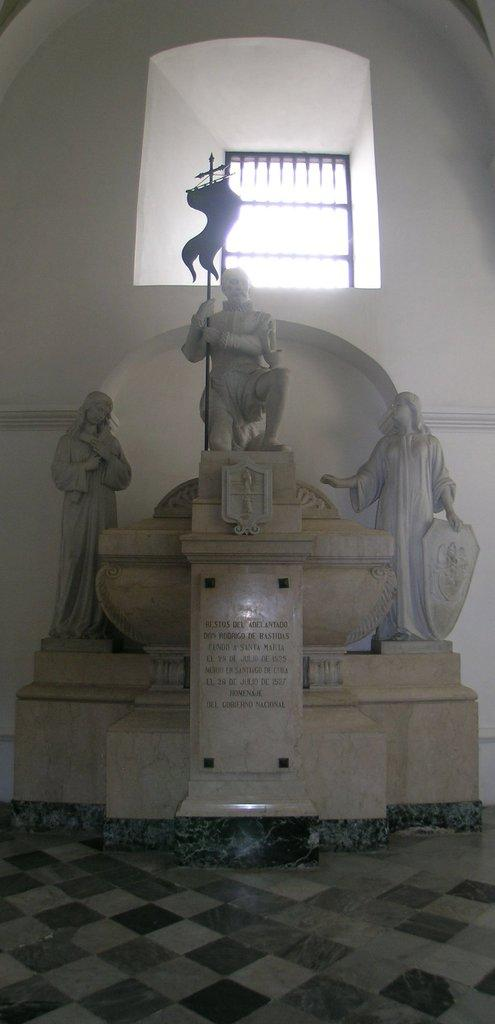What can be seen in the image? There are statues in the image. What is the middle statue holding? The middle statue is holding a flag. What is visible in the background of the image? There is a window in the backdrop of the image. What is present in the image besides the statues? There is a wall in the image. What type of weather can be seen in the image? There is no indication of weather in the image, as it features statues and a wall. Who is the manager of the statues in the image? There is no manager present in the image, as it is a static scene featuring statues and a wall. 